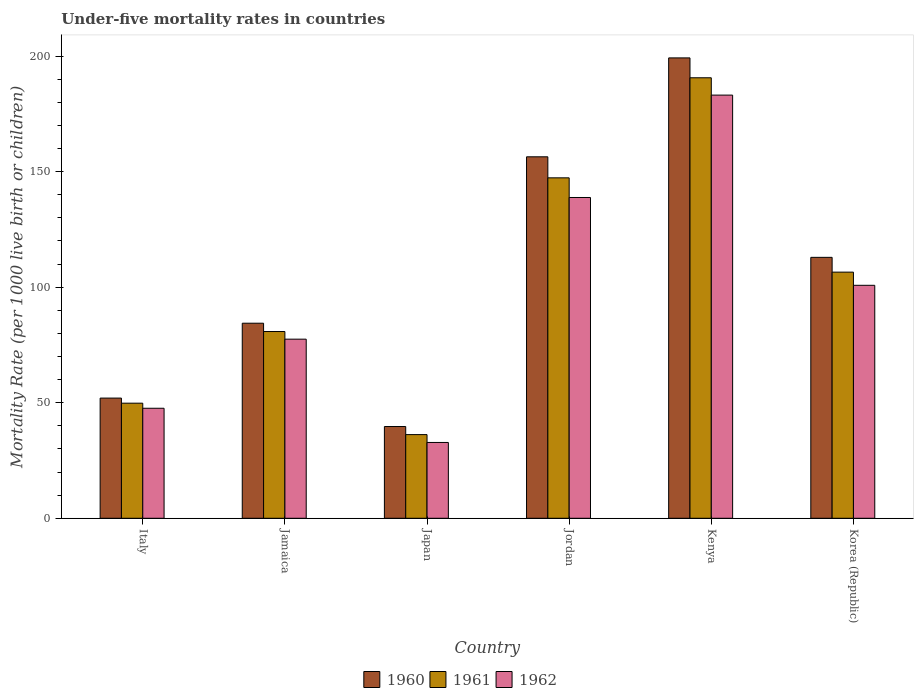How many different coloured bars are there?
Provide a succinct answer. 3. Are the number of bars per tick equal to the number of legend labels?
Ensure brevity in your answer.  Yes. How many bars are there on the 6th tick from the left?
Provide a short and direct response. 3. What is the under-five mortality rate in 1962 in Jamaica?
Your response must be concise. 77.5. Across all countries, what is the maximum under-five mortality rate in 1962?
Your answer should be compact. 183.1. Across all countries, what is the minimum under-five mortality rate in 1961?
Provide a succinct answer. 36.2. In which country was the under-five mortality rate in 1961 maximum?
Provide a short and direct response. Kenya. What is the total under-five mortality rate in 1962 in the graph?
Keep it short and to the point. 580.6. What is the difference between the under-five mortality rate in 1962 in Italy and that in Kenya?
Offer a terse response. -135.5. What is the difference between the under-five mortality rate in 1961 in Japan and the under-five mortality rate in 1960 in Kenya?
Your answer should be very brief. -163. What is the average under-five mortality rate in 1960 per country?
Make the answer very short. 107.43. What is the difference between the under-five mortality rate of/in 1960 and under-five mortality rate of/in 1962 in Jamaica?
Provide a succinct answer. 6.9. In how many countries, is the under-five mortality rate in 1961 greater than 180?
Make the answer very short. 1. What is the ratio of the under-five mortality rate in 1960 in Italy to that in Korea (Republic)?
Give a very brief answer. 0.46. Is the under-five mortality rate in 1961 in Jordan less than that in Korea (Republic)?
Offer a terse response. No. What is the difference between the highest and the second highest under-five mortality rate in 1960?
Ensure brevity in your answer.  -43.5. What is the difference between the highest and the lowest under-five mortality rate in 1960?
Offer a terse response. 159.5. What does the 2nd bar from the left in Italy represents?
Offer a very short reply. 1961. What does the 3rd bar from the right in Italy represents?
Give a very brief answer. 1960. What is the difference between two consecutive major ticks on the Y-axis?
Your response must be concise. 50. Are the values on the major ticks of Y-axis written in scientific E-notation?
Provide a succinct answer. No. Where does the legend appear in the graph?
Your response must be concise. Bottom center. How many legend labels are there?
Give a very brief answer. 3. What is the title of the graph?
Your answer should be compact. Under-five mortality rates in countries. Does "1990" appear as one of the legend labels in the graph?
Ensure brevity in your answer.  No. What is the label or title of the X-axis?
Provide a succinct answer. Country. What is the label or title of the Y-axis?
Make the answer very short. Mortality Rate (per 1000 live birth or children). What is the Mortality Rate (per 1000 live birth or children) of 1961 in Italy?
Keep it short and to the point. 49.8. What is the Mortality Rate (per 1000 live birth or children) of 1962 in Italy?
Offer a terse response. 47.6. What is the Mortality Rate (per 1000 live birth or children) in 1960 in Jamaica?
Offer a terse response. 84.4. What is the Mortality Rate (per 1000 live birth or children) in 1961 in Jamaica?
Your response must be concise. 80.8. What is the Mortality Rate (per 1000 live birth or children) in 1962 in Jamaica?
Your answer should be very brief. 77.5. What is the Mortality Rate (per 1000 live birth or children) in 1960 in Japan?
Offer a very short reply. 39.7. What is the Mortality Rate (per 1000 live birth or children) of 1961 in Japan?
Your answer should be compact. 36.2. What is the Mortality Rate (per 1000 live birth or children) of 1962 in Japan?
Your answer should be very brief. 32.8. What is the Mortality Rate (per 1000 live birth or children) in 1960 in Jordan?
Keep it short and to the point. 156.4. What is the Mortality Rate (per 1000 live birth or children) in 1961 in Jordan?
Your answer should be compact. 147.3. What is the Mortality Rate (per 1000 live birth or children) of 1962 in Jordan?
Ensure brevity in your answer.  138.8. What is the Mortality Rate (per 1000 live birth or children) of 1960 in Kenya?
Your answer should be compact. 199.2. What is the Mortality Rate (per 1000 live birth or children) in 1961 in Kenya?
Your answer should be very brief. 190.6. What is the Mortality Rate (per 1000 live birth or children) of 1962 in Kenya?
Ensure brevity in your answer.  183.1. What is the Mortality Rate (per 1000 live birth or children) of 1960 in Korea (Republic)?
Provide a short and direct response. 112.9. What is the Mortality Rate (per 1000 live birth or children) of 1961 in Korea (Republic)?
Offer a very short reply. 106.5. What is the Mortality Rate (per 1000 live birth or children) of 1962 in Korea (Republic)?
Offer a very short reply. 100.8. Across all countries, what is the maximum Mortality Rate (per 1000 live birth or children) of 1960?
Provide a succinct answer. 199.2. Across all countries, what is the maximum Mortality Rate (per 1000 live birth or children) of 1961?
Offer a very short reply. 190.6. Across all countries, what is the maximum Mortality Rate (per 1000 live birth or children) of 1962?
Ensure brevity in your answer.  183.1. Across all countries, what is the minimum Mortality Rate (per 1000 live birth or children) of 1960?
Your answer should be very brief. 39.7. Across all countries, what is the minimum Mortality Rate (per 1000 live birth or children) in 1961?
Give a very brief answer. 36.2. Across all countries, what is the minimum Mortality Rate (per 1000 live birth or children) of 1962?
Keep it short and to the point. 32.8. What is the total Mortality Rate (per 1000 live birth or children) of 1960 in the graph?
Keep it short and to the point. 644.6. What is the total Mortality Rate (per 1000 live birth or children) of 1961 in the graph?
Your response must be concise. 611.2. What is the total Mortality Rate (per 1000 live birth or children) of 1962 in the graph?
Give a very brief answer. 580.6. What is the difference between the Mortality Rate (per 1000 live birth or children) of 1960 in Italy and that in Jamaica?
Keep it short and to the point. -32.4. What is the difference between the Mortality Rate (per 1000 live birth or children) in 1961 in Italy and that in Jamaica?
Ensure brevity in your answer.  -31. What is the difference between the Mortality Rate (per 1000 live birth or children) of 1962 in Italy and that in Jamaica?
Your answer should be compact. -29.9. What is the difference between the Mortality Rate (per 1000 live birth or children) in 1961 in Italy and that in Japan?
Your response must be concise. 13.6. What is the difference between the Mortality Rate (per 1000 live birth or children) in 1962 in Italy and that in Japan?
Offer a very short reply. 14.8. What is the difference between the Mortality Rate (per 1000 live birth or children) in 1960 in Italy and that in Jordan?
Your answer should be compact. -104.4. What is the difference between the Mortality Rate (per 1000 live birth or children) in 1961 in Italy and that in Jordan?
Your response must be concise. -97.5. What is the difference between the Mortality Rate (per 1000 live birth or children) in 1962 in Italy and that in Jordan?
Give a very brief answer. -91.2. What is the difference between the Mortality Rate (per 1000 live birth or children) of 1960 in Italy and that in Kenya?
Your response must be concise. -147.2. What is the difference between the Mortality Rate (per 1000 live birth or children) of 1961 in Italy and that in Kenya?
Your answer should be very brief. -140.8. What is the difference between the Mortality Rate (per 1000 live birth or children) of 1962 in Italy and that in Kenya?
Provide a short and direct response. -135.5. What is the difference between the Mortality Rate (per 1000 live birth or children) in 1960 in Italy and that in Korea (Republic)?
Your answer should be very brief. -60.9. What is the difference between the Mortality Rate (per 1000 live birth or children) of 1961 in Italy and that in Korea (Republic)?
Provide a short and direct response. -56.7. What is the difference between the Mortality Rate (per 1000 live birth or children) of 1962 in Italy and that in Korea (Republic)?
Provide a succinct answer. -53.2. What is the difference between the Mortality Rate (per 1000 live birth or children) of 1960 in Jamaica and that in Japan?
Your answer should be very brief. 44.7. What is the difference between the Mortality Rate (per 1000 live birth or children) in 1961 in Jamaica and that in Japan?
Keep it short and to the point. 44.6. What is the difference between the Mortality Rate (per 1000 live birth or children) in 1962 in Jamaica and that in Japan?
Ensure brevity in your answer.  44.7. What is the difference between the Mortality Rate (per 1000 live birth or children) in 1960 in Jamaica and that in Jordan?
Your answer should be very brief. -72. What is the difference between the Mortality Rate (per 1000 live birth or children) in 1961 in Jamaica and that in Jordan?
Your answer should be compact. -66.5. What is the difference between the Mortality Rate (per 1000 live birth or children) of 1962 in Jamaica and that in Jordan?
Give a very brief answer. -61.3. What is the difference between the Mortality Rate (per 1000 live birth or children) of 1960 in Jamaica and that in Kenya?
Your response must be concise. -114.8. What is the difference between the Mortality Rate (per 1000 live birth or children) of 1961 in Jamaica and that in Kenya?
Give a very brief answer. -109.8. What is the difference between the Mortality Rate (per 1000 live birth or children) of 1962 in Jamaica and that in Kenya?
Your response must be concise. -105.6. What is the difference between the Mortality Rate (per 1000 live birth or children) in 1960 in Jamaica and that in Korea (Republic)?
Make the answer very short. -28.5. What is the difference between the Mortality Rate (per 1000 live birth or children) in 1961 in Jamaica and that in Korea (Republic)?
Your answer should be compact. -25.7. What is the difference between the Mortality Rate (per 1000 live birth or children) in 1962 in Jamaica and that in Korea (Republic)?
Provide a succinct answer. -23.3. What is the difference between the Mortality Rate (per 1000 live birth or children) in 1960 in Japan and that in Jordan?
Provide a succinct answer. -116.7. What is the difference between the Mortality Rate (per 1000 live birth or children) in 1961 in Japan and that in Jordan?
Provide a succinct answer. -111.1. What is the difference between the Mortality Rate (per 1000 live birth or children) in 1962 in Japan and that in Jordan?
Your response must be concise. -106. What is the difference between the Mortality Rate (per 1000 live birth or children) in 1960 in Japan and that in Kenya?
Provide a short and direct response. -159.5. What is the difference between the Mortality Rate (per 1000 live birth or children) of 1961 in Japan and that in Kenya?
Your response must be concise. -154.4. What is the difference between the Mortality Rate (per 1000 live birth or children) in 1962 in Japan and that in Kenya?
Ensure brevity in your answer.  -150.3. What is the difference between the Mortality Rate (per 1000 live birth or children) of 1960 in Japan and that in Korea (Republic)?
Offer a very short reply. -73.2. What is the difference between the Mortality Rate (per 1000 live birth or children) in 1961 in Japan and that in Korea (Republic)?
Your response must be concise. -70.3. What is the difference between the Mortality Rate (per 1000 live birth or children) of 1962 in Japan and that in Korea (Republic)?
Ensure brevity in your answer.  -68. What is the difference between the Mortality Rate (per 1000 live birth or children) in 1960 in Jordan and that in Kenya?
Provide a short and direct response. -42.8. What is the difference between the Mortality Rate (per 1000 live birth or children) of 1961 in Jordan and that in Kenya?
Provide a short and direct response. -43.3. What is the difference between the Mortality Rate (per 1000 live birth or children) of 1962 in Jordan and that in Kenya?
Your answer should be very brief. -44.3. What is the difference between the Mortality Rate (per 1000 live birth or children) of 1960 in Jordan and that in Korea (Republic)?
Provide a short and direct response. 43.5. What is the difference between the Mortality Rate (per 1000 live birth or children) in 1961 in Jordan and that in Korea (Republic)?
Give a very brief answer. 40.8. What is the difference between the Mortality Rate (per 1000 live birth or children) in 1962 in Jordan and that in Korea (Republic)?
Make the answer very short. 38. What is the difference between the Mortality Rate (per 1000 live birth or children) of 1960 in Kenya and that in Korea (Republic)?
Offer a very short reply. 86.3. What is the difference between the Mortality Rate (per 1000 live birth or children) of 1961 in Kenya and that in Korea (Republic)?
Provide a short and direct response. 84.1. What is the difference between the Mortality Rate (per 1000 live birth or children) in 1962 in Kenya and that in Korea (Republic)?
Keep it short and to the point. 82.3. What is the difference between the Mortality Rate (per 1000 live birth or children) in 1960 in Italy and the Mortality Rate (per 1000 live birth or children) in 1961 in Jamaica?
Provide a succinct answer. -28.8. What is the difference between the Mortality Rate (per 1000 live birth or children) of 1960 in Italy and the Mortality Rate (per 1000 live birth or children) of 1962 in Jamaica?
Your answer should be compact. -25.5. What is the difference between the Mortality Rate (per 1000 live birth or children) of 1961 in Italy and the Mortality Rate (per 1000 live birth or children) of 1962 in Jamaica?
Offer a terse response. -27.7. What is the difference between the Mortality Rate (per 1000 live birth or children) in 1960 in Italy and the Mortality Rate (per 1000 live birth or children) in 1962 in Japan?
Provide a succinct answer. 19.2. What is the difference between the Mortality Rate (per 1000 live birth or children) of 1960 in Italy and the Mortality Rate (per 1000 live birth or children) of 1961 in Jordan?
Give a very brief answer. -95.3. What is the difference between the Mortality Rate (per 1000 live birth or children) in 1960 in Italy and the Mortality Rate (per 1000 live birth or children) in 1962 in Jordan?
Make the answer very short. -86.8. What is the difference between the Mortality Rate (per 1000 live birth or children) in 1961 in Italy and the Mortality Rate (per 1000 live birth or children) in 1962 in Jordan?
Keep it short and to the point. -89. What is the difference between the Mortality Rate (per 1000 live birth or children) in 1960 in Italy and the Mortality Rate (per 1000 live birth or children) in 1961 in Kenya?
Offer a terse response. -138.6. What is the difference between the Mortality Rate (per 1000 live birth or children) in 1960 in Italy and the Mortality Rate (per 1000 live birth or children) in 1962 in Kenya?
Provide a short and direct response. -131.1. What is the difference between the Mortality Rate (per 1000 live birth or children) of 1961 in Italy and the Mortality Rate (per 1000 live birth or children) of 1962 in Kenya?
Your answer should be very brief. -133.3. What is the difference between the Mortality Rate (per 1000 live birth or children) of 1960 in Italy and the Mortality Rate (per 1000 live birth or children) of 1961 in Korea (Republic)?
Offer a very short reply. -54.5. What is the difference between the Mortality Rate (per 1000 live birth or children) in 1960 in Italy and the Mortality Rate (per 1000 live birth or children) in 1962 in Korea (Republic)?
Ensure brevity in your answer.  -48.8. What is the difference between the Mortality Rate (per 1000 live birth or children) in 1961 in Italy and the Mortality Rate (per 1000 live birth or children) in 1962 in Korea (Republic)?
Your answer should be very brief. -51. What is the difference between the Mortality Rate (per 1000 live birth or children) in 1960 in Jamaica and the Mortality Rate (per 1000 live birth or children) in 1961 in Japan?
Provide a succinct answer. 48.2. What is the difference between the Mortality Rate (per 1000 live birth or children) of 1960 in Jamaica and the Mortality Rate (per 1000 live birth or children) of 1962 in Japan?
Give a very brief answer. 51.6. What is the difference between the Mortality Rate (per 1000 live birth or children) in 1960 in Jamaica and the Mortality Rate (per 1000 live birth or children) in 1961 in Jordan?
Ensure brevity in your answer.  -62.9. What is the difference between the Mortality Rate (per 1000 live birth or children) of 1960 in Jamaica and the Mortality Rate (per 1000 live birth or children) of 1962 in Jordan?
Provide a succinct answer. -54.4. What is the difference between the Mortality Rate (per 1000 live birth or children) in 1961 in Jamaica and the Mortality Rate (per 1000 live birth or children) in 1962 in Jordan?
Offer a terse response. -58. What is the difference between the Mortality Rate (per 1000 live birth or children) in 1960 in Jamaica and the Mortality Rate (per 1000 live birth or children) in 1961 in Kenya?
Offer a terse response. -106.2. What is the difference between the Mortality Rate (per 1000 live birth or children) of 1960 in Jamaica and the Mortality Rate (per 1000 live birth or children) of 1962 in Kenya?
Your answer should be compact. -98.7. What is the difference between the Mortality Rate (per 1000 live birth or children) of 1961 in Jamaica and the Mortality Rate (per 1000 live birth or children) of 1962 in Kenya?
Offer a terse response. -102.3. What is the difference between the Mortality Rate (per 1000 live birth or children) of 1960 in Jamaica and the Mortality Rate (per 1000 live birth or children) of 1961 in Korea (Republic)?
Provide a short and direct response. -22.1. What is the difference between the Mortality Rate (per 1000 live birth or children) of 1960 in Jamaica and the Mortality Rate (per 1000 live birth or children) of 1962 in Korea (Republic)?
Keep it short and to the point. -16.4. What is the difference between the Mortality Rate (per 1000 live birth or children) of 1961 in Jamaica and the Mortality Rate (per 1000 live birth or children) of 1962 in Korea (Republic)?
Your answer should be very brief. -20. What is the difference between the Mortality Rate (per 1000 live birth or children) in 1960 in Japan and the Mortality Rate (per 1000 live birth or children) in 1961 in Jordan?
Your answer should be compact. -107.6. What is the difference between the Mortality Rate (per 1000 live birth or children) of 1960 in Japan and the Mortality Rate (per 1000 live birth or children) of 1962 in Jordan?
Your answer should be very brief. -99.1. What is the difference between the Mortality Rate (per 1000 live birth or children) of 1961 in Japan and the Mortality Rate (per 1000 live birth or children) of 1962 in Jordan?
Offer a very short reply. -102.6. What is the difference between the Mortality Rate (per 1000 live birth or children) in 1960 in Japan and the Mortality Rate (per 1000 live birth or children) in 1961 in Kenya?
Your response must be concise. -150.9. What is the difference between the Mortality Rate (per 1000 live birth or children) of 1960 in Japan and the Mortality Rate (per 1000 live birth or children) of 1962 in Kenya?
Provide a short and direct response. -143.4. What is the difference between the Mortality Rate (per 1000 live birth or children) in 1961 in Japan and the Mortality Rate (per 1000 live birth or children) in 1962 in Kenya?
Your response must be concise. -146.9. What is the difference between the Mortality Rate (per 1000 live birth or children) of 1960 in Japan and the Mortality Rate (per 1000 live birth or children) of 1961 in Korea (Republic)?
Offer a terse response. -66.8. What is the difference between the Mortality Rate (per 1000 live birth or children) of 1960 in Japan and the Mortality Rate (per 1000 live birth or children) of 1962 in Korea (Republic)?
Your answer should be very brief. -61.1. What is the difference between the Mortality Rate (per 1000 live birth or children) in 1961 in Japan and the Mortality Rate (per 1000 live birth or children) in 1962 in Korea (Republic)?
Offer a very short reply. -64.6. What is the difference between the Mortality Rate (per 1000 live birth or children) of 1960 in Jordan and the Mortality Rate (per 1000 live birth or children) of 1961 in Kenya?
Keep it short and to the point. -34.2. What is the difference between the Mortality Rate (per 1000 live birth or children) of 1960 in Jordan and the Mortality Rate (per 1000 live birth or children) of 1962 in Kenya?
Provide a short and direct response. -26.7. What is the difference between the Mortality Rate (per 1000 live birth or children) of 1961 in Jordan and the Mortality Rate (per 1000 live birth or children) of 1962 in Kenya?
Keep it short and to the point. -35.8. What is the difference between the Mortality Rate (per 1000 live birth or children) of 1960 in Jordan and the Mortality Rate (per 1000 live birth or children) of 1961 in Korea (Republic)?
Make the answer very short. 49.9. What is the difference between the Mortality Rate (per 1000 live birth or children) in 1960 in Jordan and the Mortality Rate (per 1000 live birth or children) in 1962 in Korea (Republic)?
Your response must be concise. 55.6. What is the difference between the Mortality Rate (per 1000 live birth or children) in 1961 in Jordan and the Mortality Rate (per 1000 live birth or children) in 1962 in Korea (Republic)?
Provide a short and direct response. 46.5. What is the difference between the Mortality Rate (per 1000 live birth or children) of 1960 in Kenya and the Mortality Rate (per 1000 live birth or children) of 1961 in Korea (Republic)?
Your answer should be compact. 92.7. What is the difference between the Mortality Rate (per 1000 live birth or children) in 1960 in Kenya and the Mortality Rate (per 1000 live birth or children) in 1962 in Korea (Republic)?
Provide a short and direct response. 98.4. What is the difference between the Mortality Rate (per 1000 live birth or children) of 1961 in Kenya and the Mortality Rate (per 1000 live birth or children) of 1962 in Korea (Republic)?
Offer a terse response. 89.8. What is the average Mortality Rate (per 1000 live birth or children) in 1960 per country?
Keep it short and to the point. 107.43. What is the average Mortality Rate (per 1000 live birth or children) of 1961 per country?
Keep it short and to the point. 101.87. What is the average Mortality Rate (per 1000 live birth or children) of 1962 per country?
Provide a short and direct response. 96.77. What is the difference between the Mortality Rate (per 1000 live birth or children) in 1960 and Mortality Rate (per 1000 live birth or children) in 1961 in Jamaica?
Your response must be concise. 3.6. What is the difference between the Mortality Rate (per 1000 live birth or children) in 1960 and Mortality Rate (per 1000 live birth or children) in 1961 in Japan?
Offer a very short reply. 3.5. What is the difference between the Mortality Rate (per 1000 live birth or children) in 1960 and Mortality Rate (per 1000 live birth or children) in 1961 in Jordan?
Your answer should be very brief. 9.1. What is the difference between the Mortality Rate (per 1000 live birth or children) in 1961 and Mortality Rate (per 1000 live birth or children) in 1962 in Jordan?
Your answer should be very brief. 8.5. What is the difference between the Mortality Rate (per 1000 live birth or children) in 1960 and Mortality Rate (per 1000 live birth or children) in 1961 in Korea (Republic)?
Give a very brief answer. 6.4. What is the ratio of the Mortality Rate (per 1000 live birth or children) of 1960 in Italy to that in Jamaica?
Your response must be concise. 0.62. What is the ratio of the Mortality Rate (per 1000 live birth or children) in 1961 in Italy to that in Jamaica?
Provide a succinct answer. 0.62. What is the ratio of the Mortality Rate (per 1000 live birth or children) of 1962 in Italy to that in Jamaica?
Your response must be concise. 0.61. What is the ratio of the Mortality Rate (per 1000 live birth or children) of 1960 in Italy to that in Japan?
Your answer should be very brief. 1.31. What is the ratio of the Mortality Rate (per 1000 live birth or children) in 1961 in Italy to that in Japan?
Keep it short and to the point. 1.38. What is the ratio of the Mortality Rate (per 1000 live birth or children) in 1962 in Italy to that in Japan?
Your response must be concise. 1.45. What is the ratio of the Mortality Rate (per 1000 live birth or children) in 1960 in Italy to that in Jordan?
Offer a very short reply. 0.33. What is the ratio of the Mortality Rate (per 1000 live birth or children) in 1961 in Italy to that in Jordan?
Ensure brevity in your answer.  0.34. What is the ratio of the Mortality Rate (per 1000 live birth or children) in 1962 in Italy to that in Jordan?
Keep it short and to the point. 0.34. What is the ratio of the Mortality Rate (per 1000 live birth or children) of 1960 in Italy to that in Kenya?
Provide a succinct answer. 0.26. What is the ratio of the Mortality Rate (per 1000 live birth or children) in 1961 in Italy to that in Kenya?
Give a very brief answer. 0.26. What is the ratio of the Mortality Rate (per 1000 live birth or children) of 1962 in Italy to that in Kenya?
Keep it short and to the point. 0.26. What is the ratio of the Mortality Rate (per 1000 live birth or children) in 1960 in Italy to that in Korea (Republic)?
Your answer should be compact. 0.46. What is the ratio of the Mortality Rate (per 1000 live birth or children) of 1961 in Italy to that in Korea (Republic)?
Give a very brief answer. 0.47. What is the ratio of the Mortality Rate (per 1000 live birth or children) of 1962 in Italy to that in Korea (Republic)?
Offer a terse response. 0.47. What is the ratio of the Mortality Rate (per 1000 live birth or children) of 1960 in Jamaica to that in Japan?
Your response must be concise. 2.13. What is the ratio of the Mortality Rate (per 1000 live birth or children) of 1961 in Jamaica to that in Japan?
Ensure brevity in your answer.  2.23. What is the ratio of the Mortality Rate (per 1000 live birth or children) in 1962 in Jamaica to that in Japan?
Provide a short and direct response. 2.36. What is the ratio of the Mortality Rate (per 1000 live birth or children) of 1960 in Jamaica to that in Jordan?
Give a very brief answer. 0.54. What is the ratio of the Mortality Rate (per 1000 live birth or children) of 1961 in Jamaica to that in Jordan?
Provide a succinct answer. 0.55. What is the ratio of the Mortality Rate (per 1000 live birth or children) in 1962 in Jamaica to that in Jordan?
Your response must be concise. 0.56. What is the ratio of the Mortality Rate (per 1000 live birth or children) in 1960 in Jamaica to that in Kenya?
Make the answer very short. 0.42. What is the ratio of the Mortality Rate (per 1000 live birth or children) of 1961 in Jamaica to that in Kenya?
Provide a short and direct response. 0.42. What is the ratio of the Mortality Rate (per 1000 live birth or children) in 1962 in Jamaica to that in Kenya?
Your response must be concise. 0.42. What is the ratio of the Mortality Rate (per 1000 live birth or children) of 1960 in Jamaica to that in Korea (Republic)?
Ensure brevity in your answer.  0.75. What is the ratio of the Mortality Rate (per 1000 live birth or children) of 1961 in Jamaica to that in Korea (Republic)?
Make the answer very short. 0.76. What is the ratio of the Mortality Rate (per 1000 live birth or children) in 1962 in Jamaica to that in Korea (Republic)?
Offer a terse response. 0.77. What is the ratio of the Mortality Rate (per 1000 live birth or children) of 1960 in Japan to that in Jordan?
Give a very brief answer. 0.25. What is the ratio of the Mortality Rate (per 1000 live birth or children) of 1961 in Japan to that in Jordan?
Offer a very short reply. 0.25. What is the ratio of the Mortality Rate (per 1000 live birth or children) of 1962 in Japan to that in Jordan?
Keep it short and to the point. 0.24. What is the ratio of the Mortality Rate (per 1000 live birth or children) in 1960 in Japan to that in Kenya?
Offer a very short reply. 0.2. What is the ratio of the Mortality Rate (per 1000 live birth or children) in 1961 in Japan to that in Kenya?
Keep it short and to the point. 0.19. What is the ratio of the Mortality Rate (per 1000 live birth or children) in 1962 in Japan to that in Kenya?
Your answer should be very brief. 0.18. What is the ratio of the Mortality Rate (per 1000 live birth or children) of 1960 in Japan to that in Korea (Republic)?
Keep it short and to the point. 0.35. What is the ratio of the Mortality Rate (per 1000 live birth or children) of 1961 in Japan to that in Korea (Republic)?
Ensure brevity in your answer.  0.34. What is the ratio of the Mortality Rate (per 1000 live birth or children) in 1962 in Japan to that in Korea (Republic)?
Offer a terse response. 0.33. What is the ratio of the Mortality Rate (per 1000 live birth or children) in 1960 in Jordan to that in Kenya?
Offer a terse response. 0.79. What is the ratio of the Mortality Rate (per 1000 live birth or children) in 1961 in Jordan to that in Kenya?
Offer a very short reply. 0.77. What is the ratio of the Mortality Rate (per 1000 live birth or children) in 1962 in Jordan to that in Kenya?
Make the answer very short. 0.76. What is the ratio of the Mortality Rate (per 1000 live birth or children) of 1960 in Jordan to that in Korea (Republic)?
Ensure brevity in your answer.  1.39. What is the ratio of the Mortality Rate (per 1000 live birth or children) of 1961 in Jordan to that in Korea (Republic)?
Provide a short and direct response. 1.38. What is the ratio of the Mortality Rate (per 1000 live birth or children) in 1962 in Jordan to that in Korea (Republic)?
Your answer should be compact. 1.38. What is the ratio of the Mortality Rate (per 1000 live birth or children) in 1960 in Kenya to that in Korea (Republic)?
Your response must be concise. 1.76. What is the ratio of the Mortality Rate (per 1000 live birth or children) in 1961 in Kenya to that in Korea (Republic)?
Provide a short and direct response. 1.79. What is the ratio of the Mortality Rate (per 1000 live birth or children) of 1962 in Kenya to that in Korea (Republic)?
Make the answer very short. 1.82. What is the difference between the highest and the second highest Mortality Rate (per 1000 live birth or children) of 1960?
Offer a very short reply. 42.8. What is the difference between the highest and the second highest Mortality Rate (per 1000 live birth or children) of 1961?
Provide a short and direct response. 43.3. What is the difference between the highest and the second highest Mortality Rate (per 1000 live birth or children) of 1962?
Keep it short and to the point. 44.3. What is the difference between the highest and the lowest Mortality Rate (per 1000 live birth or children) in 1960?
Make the answer very short. 159.5. What is the difference between the highest and the lowest Mortality Rate (per 1000 live birth or children) in 1961?
Your answer should be very brief. 154.4. What is the difference between the highest and the lowest Mortality Rate (per 1000 live birth or children) in 1962?
Offer a very short reply. 150.3. 